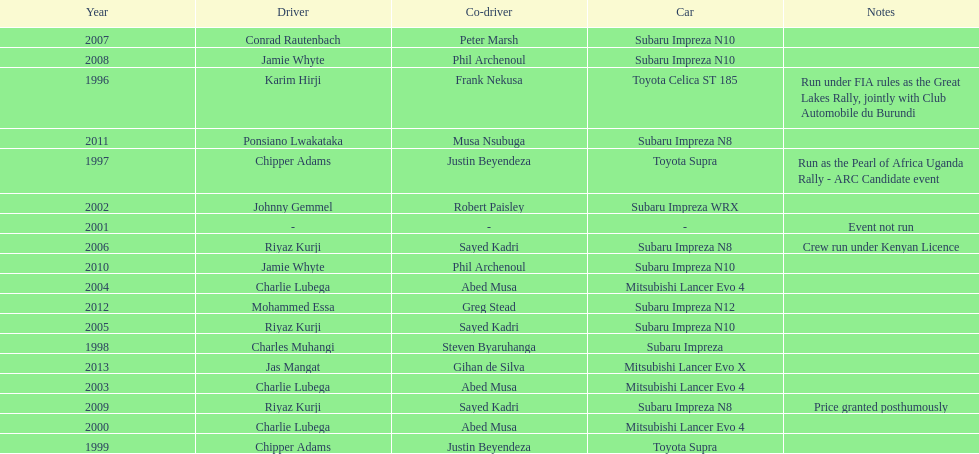How many drivers are racing with a co-driver from a different country? 1. 